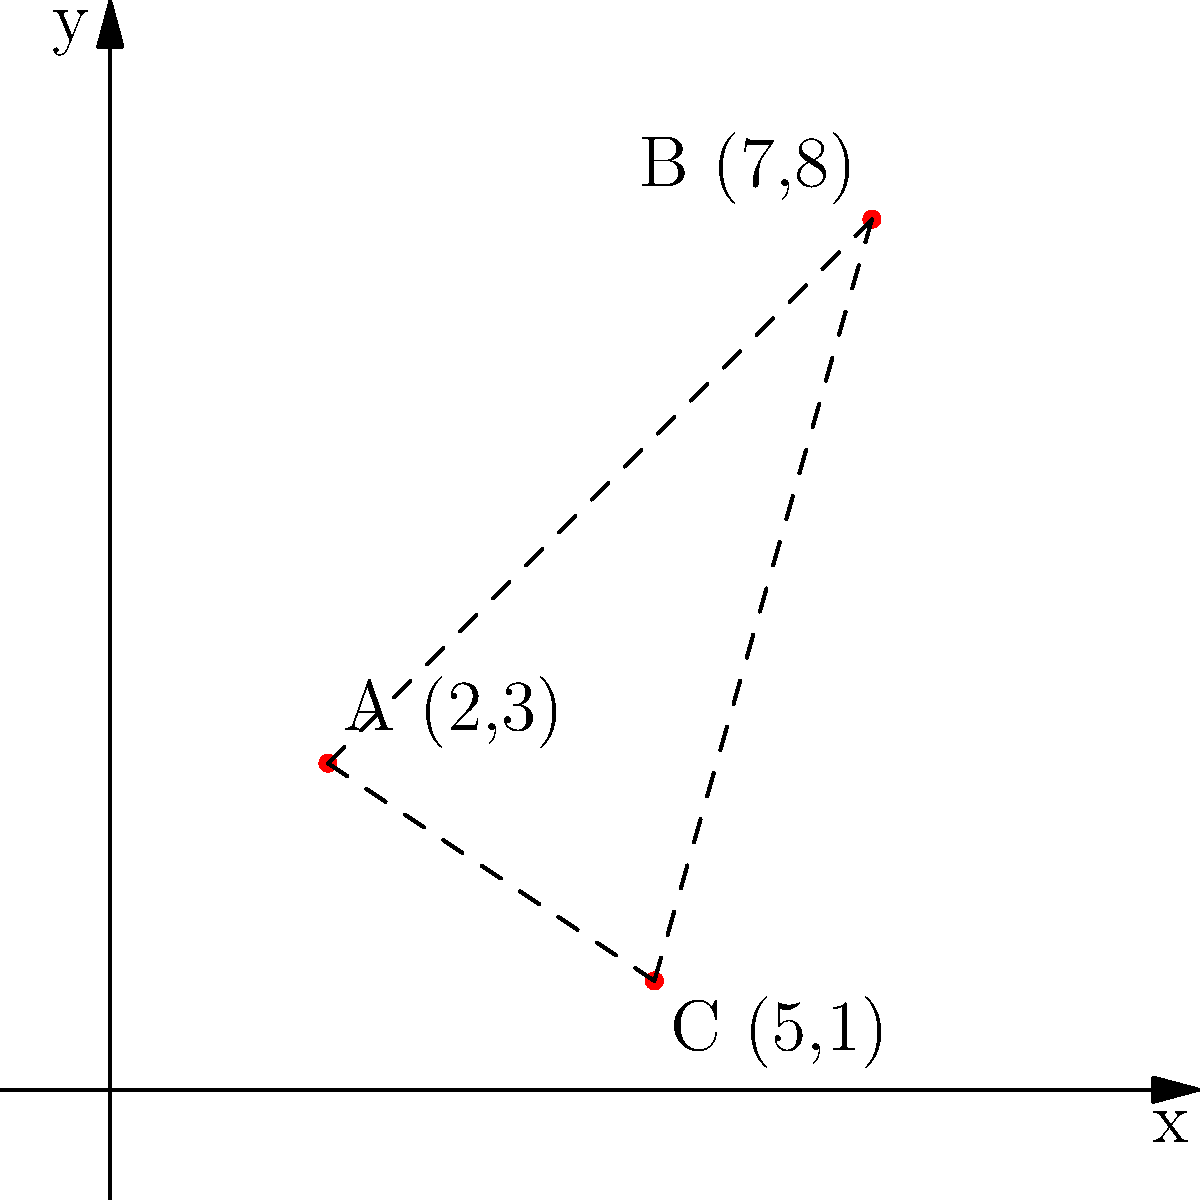Three maximum security prisons housing death row inmates are located on a coordinate plane as shown in the graph. Prison A is at (2,3), Prison B is at (7,8), and Prison C is at (5,1). Calculate the total distance that would need to be traveled to visit all three prisons in the order A → B → C → A. Round your answer to two decimal places. To solve this problem, we need to calculate the distances between each pair of prisons and sum them up. We can use the distance formula between two points: $d = \sqrt{(x_2-x_1)^2 + (y_2-y_1)^2}$

Step 1: Calculate distance from A to B
$d_{AB} = \sqrt{(7-2)^2 + (8-3)^2} = \sqrt{5^2 + 5^2} = \sqrt{50} = 5\sqrt{2} \approx 7.07$

Step 2: Calculate distance from B to C
$d_{BC} = \sqrt{(5-7)^2 + (1-8)^2} = \sqrt{(-2)^2 + (-7)^2} = \sqrt{4 + 49} = \sqrt{53} \approx 7.28$

Step 3: Calculate distance from C to A
$d_{CA} = \sqrt{(2-5)^2 + (3-1)^2} = \sqrt{(-3)^2 + 2^2} = \sqrt{9 + 4} = \sqrt{13} \approx 3.61$

Step 4: Sum up all distances
Total distance = $d_{AB} + d_{BC} + d_{CA} = 7.07 + 7.28 + 3.61 = 17.96$

Rounding to two decimal places, we get 17.96 units.
Answer: 17.96 units 